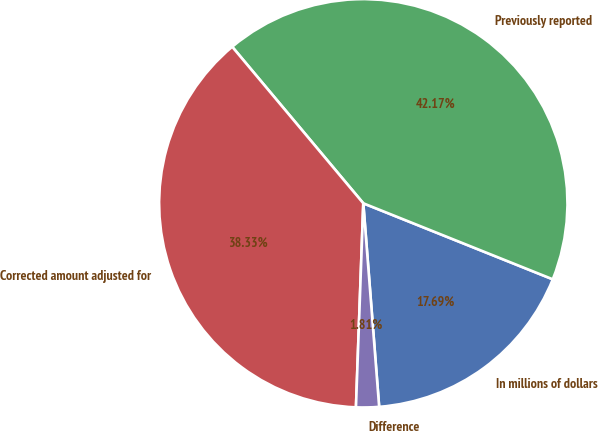<chart> <loc_0><loc_0><loc_500><loc_500><pie_chart><fcel>In millions of dollars<fcel>Previously reported<fcel>Corrected amount adjusted for<fcel>Difference<nl><fcel>17.69%<fcel>42.17%<fcel>38.33%<fcel>1.81%<nl></chart> 